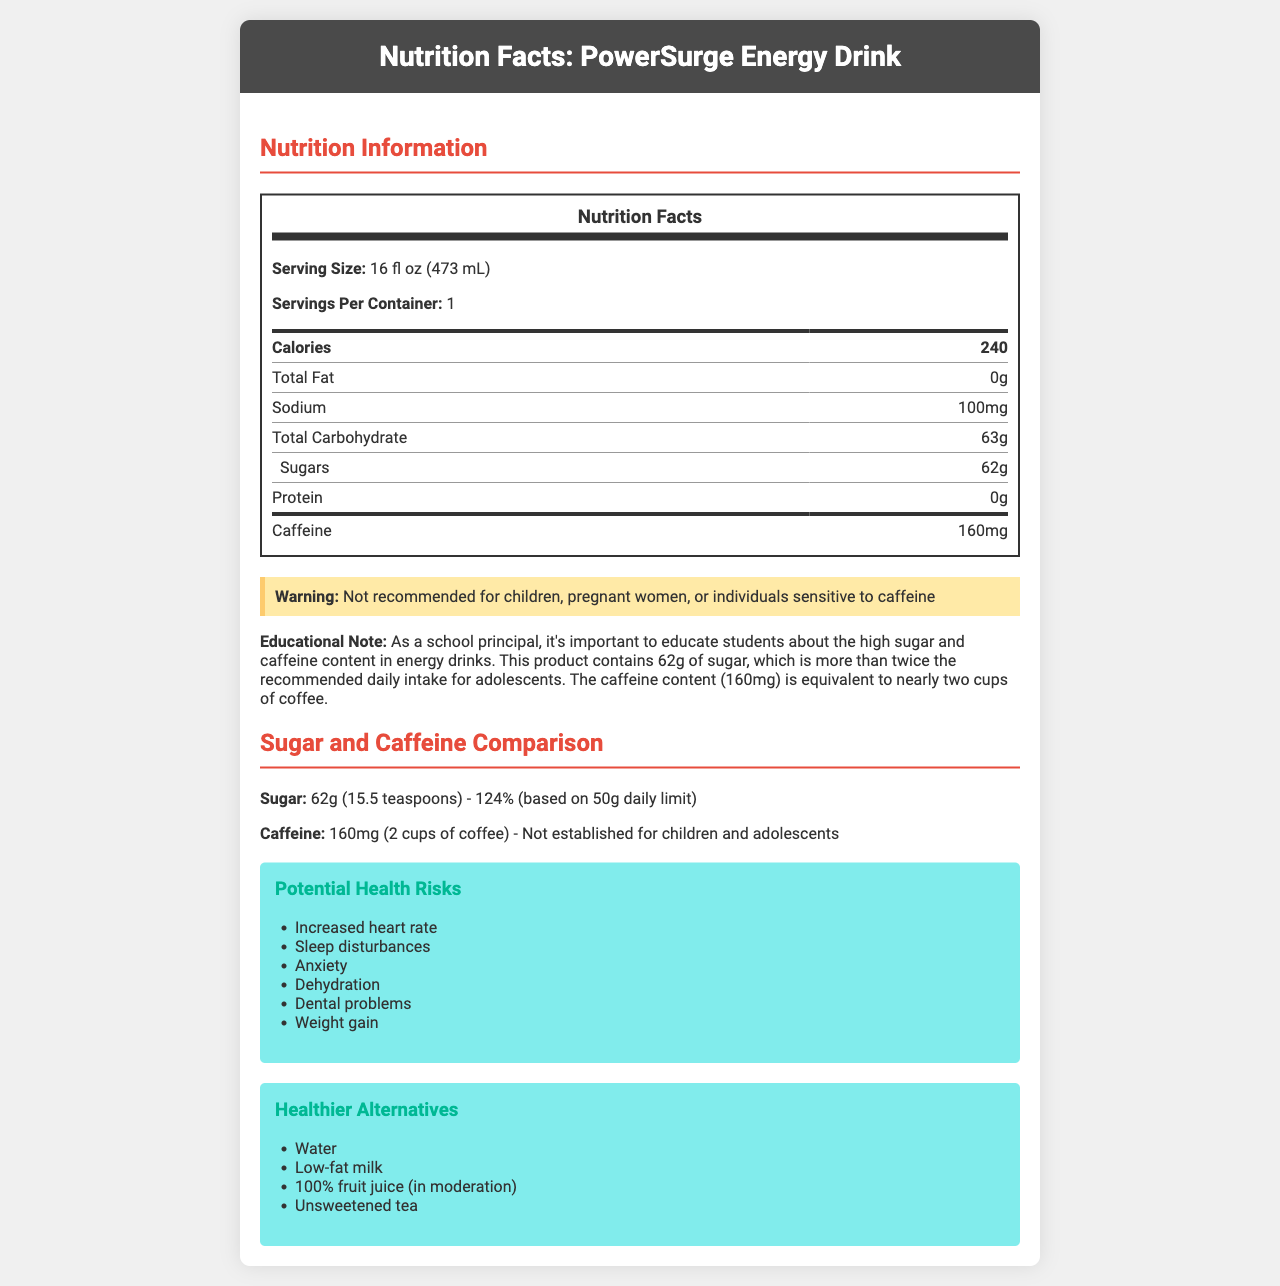what is the serving size of PowerSurge Energy Drink? The serving size is clearly listed in the "Nutrition Information" section of the document.
Answer: 16 fl oz (473 mL) how many calories does one serving of PowerSurge Energy Drink contain? The calorie content per serving is mentioned in the "Nutrition Information" section under "Calories."
Answer: 240 calories how much sugar does PowerSurge Energy Drink contain per serving? The amount of sugar per serving is specified under the "Nutrition Information" section for "Sugars."
Answer: 62g how much caffeine is in one serving of PowerSurge Energy Drink? The amount of caffeine per serving is found in the "Nutrition Information" section under "Caffeine."
Answer: 160mg what is the content of vitamin B6 in terms of daily value percentage in PowerSurge Energy Drink? The daily value percentage for vitamin B6 is listed under the "Nutrition Information" section.
Answer: 250% DV what are the potential health risks associated with consuming PowerSurge Energy Drink? A. Improved athletic performance B. Increased heart rate C. Enhanced concentration D. Dental problems The document lists "Increased heart rate" and "Dental problems" as potential health risks under the "Potential Health Risks" section.
Answer: B and D which ingredient is not found in PowerSurge Energy Drink? A. High Fructose Corn Syrup B. Ginseng Extract C. Green Tea Extract D. Citric Acid "Green Tea Extract" is not listed among the ingredients, while all other options are.
Answer: C is PowerSurge Energy Drink recommended for children? The warning section clearly states that it is "Not recommended for children."
Answer: No can the document provide information about the exact caffeine limit for children and adolescents? The document states that the "percent daily value" for caffeine is "Not established for children and adolescents."
Answer: No what is the main idea of the document? This answer captures the essential content of the document, including the nutritional details, health warnings, and alternative recommendations.
Answer: The document is a detailed nutrition facts label for PowerSurge Energy Drink, highlighting its high sugar and caffeine content, potential health risks, and offering healthier alternatives for students. what is the manufacturing date of PowerSurge Energy Drink? The document does not provide information about the manufacturing date of the product.
Answer: Cannot be determined 